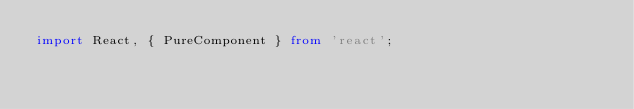Convert code to text. <code><loc_0><loc_0><loc_500><loc_500><_TypeScript_>import React, { PureComponent } from 'react';</code> 